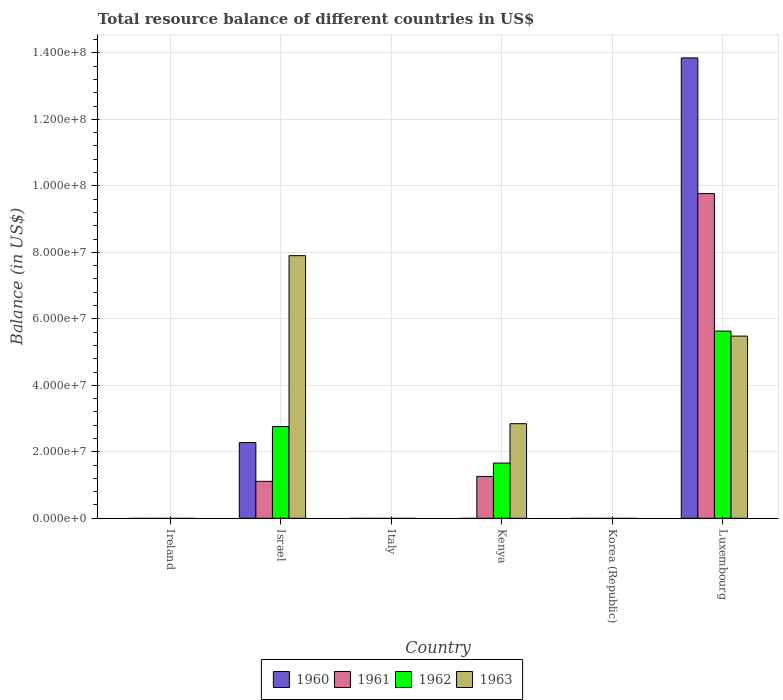How many different coloured bars are there?
Your response must be concise. 4. Are the number of bars per tick equal to the number of legend labels?
Offer a terse response. No. How many bars are there on the 5th tick from the left?
Offer a terse response. 0. How many bars are there on the 6th tick from the right?
Provide a succinct answer. 0. What is the total resource balance in 1963 in Israel?
Keep it short and to the point. 7.90e+07. Across all countries, what is the maximum total resource balance in 1961?
Your answer should be very brief. 9.77e+07. Across all countries, what is the minimum total resource balance in 1963?
Give a very brief answer. 0. In which country was the total resource balance in 1961 maximum?
Your answer should be very brief. Luxembourg. What is the total total resource balance in 1961 in the graph?
Make the answer very short. 1.21e+08. What is the difference between the total resource balance in 1961 in Israel and that in Luxembourg?
Your response must be concise. -8.66e+07. What is the difference between the total resource balance in 1961 in Luxembourg and the total resource balance in 1963 in Israel?
Provide a short and direct response. 1.87e+07. What is the average total resource balance in 1960 per country?
Your response must be concise. 2.69e+07. What is the difference between the total resource balance of/in 1962 and total resource balance of/in 1963 in Luxembourg?
Your answer should be very brief. 1.52e+06. What is the ratio of the total resource balance in 1963 in Kenya to that in Luxembourg?
Your answer should be very brief. 0.52. Is the total resource balance in 1963 in Kenya less than that in Luxembourg?
Ensure brevity in your answer.  Yes. What is the difference between the highest and the second highest total resource balance in 1963?
Make the answer very short. 5.06e+07. What is the difference between the highest and the lowest total resource balance in 1960?
Keep it short and to the point. 1.38e+08. In how many countries, is the total resource balance in 1961 greater than the average total resource balance in 1961 taken over all countries?
Provide a short and direct response. 1. Is the sum of the total resource balance in 1960 in Israel and Luxembourg greater than the maximum total resource balance in 1963 across all countries?
Your answer should be very brief. Yes. Is it the case that in every country, the sum of the total resource balance in 1963 and total resource balance in 1960 is greater than the total resource balance in 1961?
Give a very brief answer. No. How many bars are there?
Offer a very short reply. 11. How many countries are there in the graph?
Provide a short and direct response. 6. How are the legend labels stacked?
Give a very brief answer. Horizontal. What is the title of the graph?
Make the answer very short. Total resource balance of different countries in US$. Does "1960" appear as one of the legend labels in the graph?
Ensure brevity in your answer.  Yes. What is the label or title of the X-axis?
Your response must be concise. Country. What is the label or title of the Y-axis?
Offer a terse response. Balance (in US$). What is the Balance (in US$) of 1961 in Ireland?
Your answer should be compact. 0. What is the Balance (in US$) in 1962 in Ireland?
Offer a terse response. 0. What is the Balance (in US$) in 1963 in Ireland?
Your answer should be compact. 0. What is the Balance (in US$) in 1960 in Israel?
Make the answer very short. 2.28e+07. What is the Balance (in US$) of 1961 in Israel?
Offer a terse response. 1.11e+07. What is the Balance (in US$) in 1962 in Israel?
Your response must be concise. 2.76e+07. What is the Balance (in US$) of 1963 in Israel?
Your answer should be compact. 7.90e+07. What is the Balance (in US$) in 1960 in Italy?
Offer a very short reply. 0. What is the Balance (in US$) in 1961 in Italy?
Ensure brevity in your answer.  0. What is the Balance (in US$) in 1960 in Kenya?
Provide a succinct answer. 0. What is the Balance (in US$) of 1961 in Kenya?
Provide a short and direct response. 1.26e+07. What is the Balance (in US$) of 1962 in Kenya?
Ensure brevity in your answer.  1.66e+07. What is the Balance (in US$) in 1963 in Kenya?
Make the answer very short. 2.84e+07. What is the Balance (in US$) of 1960 in Korea (Republic)?
Your answer should be compact. 0. What is the Balance (in US$) in 1961 in Korea (Republic)?
Provide a short and direct response. 0. What is the Balance (in US$) of 1962 in Korea (Republic)?
Your answer should be very brief. 0. What is the Balance (in US$) in 1960 in Luxembourg?
Offer a very short reply. 1.38e+08. What is the Balance (in US$) of 1961 in Luxembourg?
Ensure brevity in your answer.  9.77e+07. What is the Balance (in US$) in 1962 in Luxembourg?
Offer a terse response. 5.63e+07. What is the Balance (in US$) of 1963 in Luxembourg?
Give a very brief answer. 5.48e+07. Across all countries, what is the maximum Balance (in US$) of 1960?
Offer a terse response. 1.38e+08. Across all countries, what is the maximum Balance (in US$) in 1961?
Your response must be concise. 9.77e+07. Across all countries, what is the maximum Balance (in US$) of 1962?
Provide a short and direct response. 5.63e+07. Across all countries, what is the maximum Balance (in US$) of 1963?
Provide a succinct answer. 7.90e+07. Across all countries, what is the minimum Balance (in US$) of 1963?
Provide a succinct answer. 0. What is the total Balance (in US$) of 1960 in the graph?
Provide a succinct answer. 1.61e+08. What is the total Balance (in US$) in 1961 in the graph?
Offer a very short reply. 1.21e+08. What is the total Balance (in US$) of 1962 in the graph?
Offer a terse response. 1.01e+08. What is the total Balance (in US$) of 1963 in the graph?
Provide a succinct answer. 1.62e+08. What is the difference between the Balance (in US$) of 1961 in Israel and that in Kenya?
Ensure brevity in your answer.  -1.47e+06. What is the difference between the Balance (in US$) in 1962 in Israel and that in Kenya?
Keep it short and to the point. 1.10e+07. What is the difference between the Balance (in US$) in 1963 in Israel and that in Kenya?
Provide a succinct answer. 5.06e+07. What is the difference between the Balance (in US$) of 1960 in Israel and that in Luxembourg?
Give a very brief answer. -1.16e+08. What is the difference between the Balance (in US$) of 1961 in Israel and that in Luxembourg?
Your answer should be compact. -8.66e+07. What is the difference between the Balance (in US$) in 1962 in Israel and that in Luxembourg?
Offer a terse response. -2.87e+07. What is the difference between the Balance (in US$) of 1963 in Israel and that in Luxembourg?
Offer a terse response. 2.42e+07. What is the difference between the Balance (in US$) of 1961 in Kenya and that in Luxembourg?
Your answer should be very brief. -8.51e+07. What is the difference between the Balance (in US$) in 1962 in Kenya and that in Luxembourg?
Make the answer very short. -3.97e+07. What is the difference between the Balance (in US$) of 1963 in Kenya and that in Luxembourg?
Your response must be concise. -2.64e+07. What is the difference between the Balance (in US$) of 1960 in Israel and the Balance (in US$) of 1961 in Kenya?
Offer a very short reply. 1.02e+07. What is the difference between the Balance (in US$) of 1960 in Israel and the Balance (in US$) of 1962 in Kenya?
Your answer should be compact. 6.17e+06. What is the difference between the Balance (in US$) in 1960 in Israel and the Balance (in US$) in 1963 in Kenya?
Ensure brevity in your answer.  -5.67e+06. What is the difference between the Balance (in US$) in 1961 in Israel and the Balance (in US$) in 1962 in Kenya?
Ensure brevity in your answer.  -5.49e+06. What is the difference between the Balance (in US$) of 1961 in Israel and the Balance (in US$) of 1963 in Kenya?
Offer a very short reply. -1.73e+07. What is the difference between the Balance (in US$) of 1962 in Israel and the Balance (in US$) of 1963 in Kenya?
Your answer should be compact. -8.62e+05. What is the difference between the Balance (in US$) of 1960 in Israel and the Balance (in US$) of 1961 in Luxembourg?
Make the answer very short. -7.49e+07. What is the difference between the Balance (in US$) in 1960 in Israel and the Balance (in US$) in 1962 in Luxembourg?
Offer a very short reply. -3.35e+07. What is the difference between the Balance (in US$) in 1960 in Israel and the Balance (in US$) in 1963 in Luxembourg?
Ensure brevity in your answer.  -3.20e+07. What is the difference between the Balance (in US$) in 1961 in Israel and the Balance (in US$) in 1962 in Luxembourg?
Offer a terse response. -4.52e+07. What is the difference between the Balance (in US$) of 1961 in Israel and the Balance (in US$) of 1963 in Luxembourg?
Your answer should be very brief. -4.37e+07. What is the difference between the Balance (in US$) in 1962 in Israel and the Balance (in US$) in 1963 in Luxembourg?
Offer a terse response. -2.72e+07. What is the difference between the Balance (in US$) of 1961 in Kenya and the Balance (in US$) of 1962 in Luxembourg?
Provide a short and direct response. -4.37e+07. What is the difference between the Balance (in US$) in 1961 in Kenya and the Balance (in US$) in 1963 in Luxembourg?
Your answer should be compact. -4.22e+07. What is the difference between the Balance (in US$) of 1962 in Kenya and the Balance (in US$) of 1963 in Luxembourg?
Make the answer very short. -3.82e+07. What is the average Balance (in US$) of 1960 per country?
Offer a terse response. 2.69e+07. What is the average Balance (in US$) in 1961 per country?
Your response must be concise. 2.02e+07. What is the average Balance (in US$) of 1962 per country?
Offer a very short reply. 1.68e+07. What is the average Balance (in US$) of 1963 per country?
Provide a short and direct response. 2.70e+07. What is the difference between the Balance (in US$) of 1960 and Balance (in US$) of 1961 in Israel?
Make the answer very short. 1.17e+07. What is the difference between the Balance (in US$) in 1960 and Balance (in US$) in 1962 in Israel?
Ensure brevity in your answer.  -4.81e+06. What is the difference between the Balance (in US$) in 1960 and Balance (in US$) in 1963 in Israel?
Offer a very short reply. -5.62e+07. What is the difference between the Balance (in US$) in 1961 and Balance (in US$) in 1962 in Israel?
Make the answer very short. -1.65e+07. What is the difference between the Balance (in US$) in 1961 and Balance (in US$) in 1963 in Israel?
Offer a terse response. -6.79e+07. What is the difference between the Balance (in US$) in 1962 and Balance (in US$) in 1963 in Israel?
Give a very brief answer. -5.14e+07. What is the difference between the Balance (in US$) of 1961 and Balance (in US$) of 1962 in Kenya?
Provide a succinct answer. -4.02e+06. What is the difference between the Balance (in US$) of 1961 and Balance (in US$) of 1963 in Kenya?
Ensure brevity in your answer.  -1.59e+07. What is the difference between the Balance (in US$) in 1962 and Balance (in US$) in 1963 in Kenya?
Give a very brief answer. -1.18e+07. What is the difference between the Balance (in US$) in 1960 and Balance (in US$) in 1961 in Luxembourg?
Keep it short and to the point. 4.08e+07. What is the difference between the Balance (in US$) of 1960 and Balance (in US$) of 1962 in Luxembourg?
Your response must be concise. 8.22e+07. What is the difference between the Balance (in US$) of 1960 and Balance (in US$) of 1963 in Luxembourg?
Ensure brevity in your answer.  8.37e+07. What is the difference between the Balance (in US$) in 1961 and Balance (in US$) in 1962 in Luxembourg?
Offer a very short reply. 4.13e+07. What is the difference between the Balance (in US$) in 1961 and Balance (in US$) in 1963 in Luxembourg?
Keep it short and to the point. 4.29e+07. What is the difference between the Balance (in US$) of 1962 and Balance (in US$) of 1963 in Luxembourg?
Your response must be concise. 1.52e+06. What is the ratio of the Balance (in US$) in 1961 in Israel to that in Kenya?
Offer a terse response. 0.88. What is the ratio of the Balance (in US$) of 1962 in Israel to that in Kenya?
Provide a short and direct response. 1.66. What is the ratio of the Balance (in US$) of 1963 in Israel to that in Kenya?
Your answer should be very brief. 2.78. What is the ratio of the Balance (in US$) of 1960 in Israel to that in Luxembourg?
Your response must be concise. 0.16. What is the ratio of the Balance (in US$) in 1961 in Israel to that in Luxembourg?
Give a very brief answer. 0.11. What is the ratio of the Balance (in US$) of 1962 in Israel to that in Luxembourg?
Provide a succinct answer. 0.49. What is the ratio of the Balance (in US$) in 1963 in Israel to that in Luxembourg?
Make the answer very short. 1.44. What is the ratio of the Balance (in US$) of 1961 in Kenya to that in Luxembourg?
Offer a terse response. 0.13. What is the ratio of the Balance (in US$) of 1962 in Kenya to that in Luxembourg?
Offer a terse response. 0.29. What is the ratio of the Balance (in US$) in 1963 in Kenya to that in Luxembourg?
Offer a very short reply. 0.52. What is the difference between the highest and the second highest Balance (in US$) in 1961?
Give a very brief answer. 8.51e+07. What is the difference between the highest and the second highest Balance (in US$) of 1962?
Keep it short and to the point. 2.87e+07. What is the difference between the highest and the second highest Balance (in US$) in 1963?
Your answer should be very brief. 2.42e+07. What is the difference between the highest and the lowest Balance (in US$) in 1960?
Provide a short and direct response. 1.38e+08. What is the difference between the highest and the lowest Balance (in US$) of 1961?
Give a very brief answer. 9.77e+07. What is the difference between the highest and the lowest Balance (in US$) of 1962?
Make the answer very short. 5.63e+07. What is the difference between the highest and the lowest Balance (in US$) of 1963?
Provide a short and direct response. 7.90e+07. 